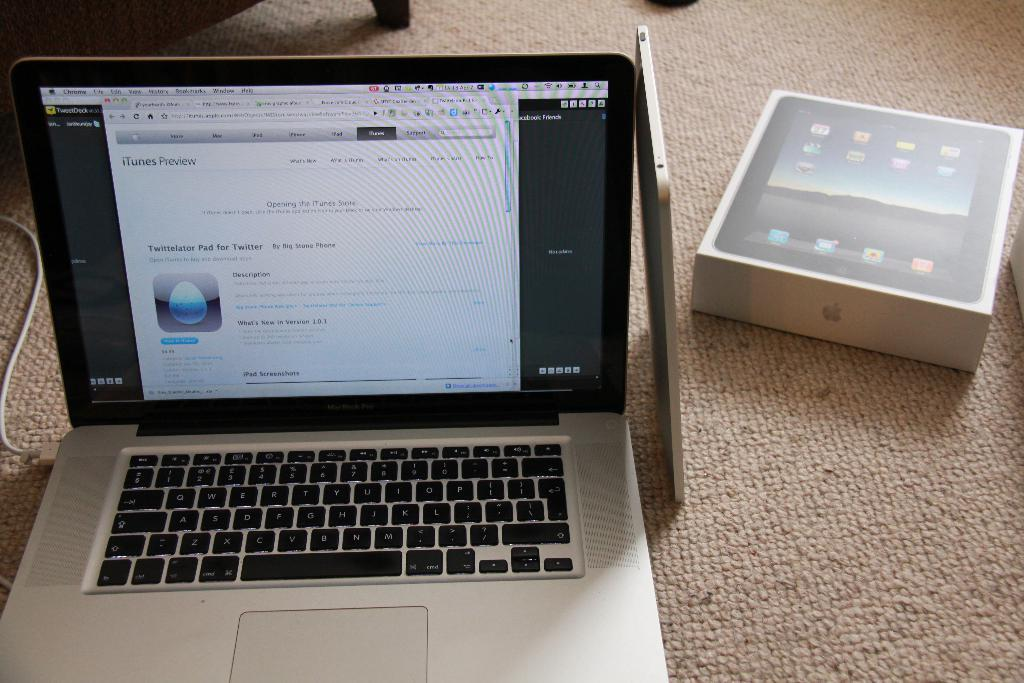<image>
Describe the image concisely. A macbook opened to an iTunes preview showing the app Twittelator. 